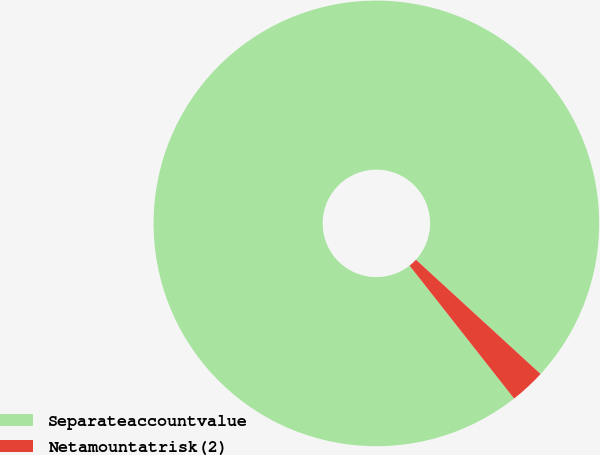Convert chart. <chart><loc_0><loc_0><loc_500><loc_500><pie_chart><fcel>Separateaccountvalue<fcel>Netamountatrisk(2)<nl><fcel>97.42%<fcel>2.58%<nl></chart> 